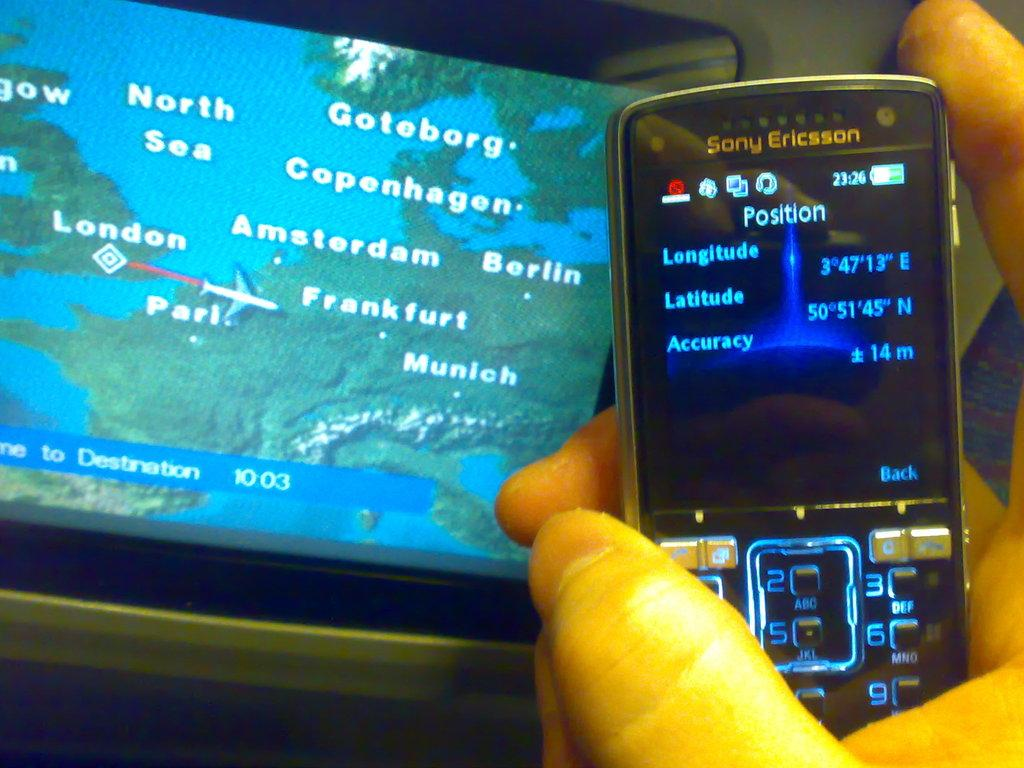<image>
Render a clear and concise summary of the photo. A Sony Ericsson phone shows a set of coordinates. 